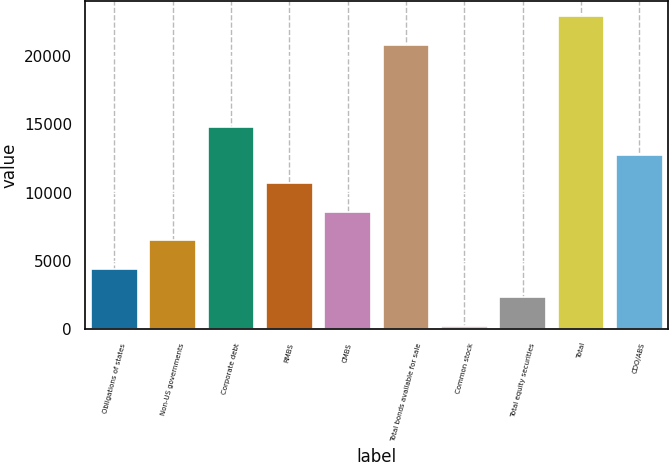Convert chart to OTSL. <chart><loc_0><loc_0><loc_500><loc_500><bar_chart><fcel>Obligations of states<fcel>Non-US governments<fcel>Corporate debt<fcel>RMBS<fcel>CMBS<fcel>Total bonds available for sale<fcel>Common stock<fcel>Total equity securities<fcel>Total<fcel>CDO/ABS<nl><fcel>4431.2<fcel>6514.3<fcel>14846.7<fcel>10680.5<fcel>8597.4<fcel>20828<fcel>265<fcel>2348.1<fcel>22911.1<fcel>12763.6<nl></chart> 